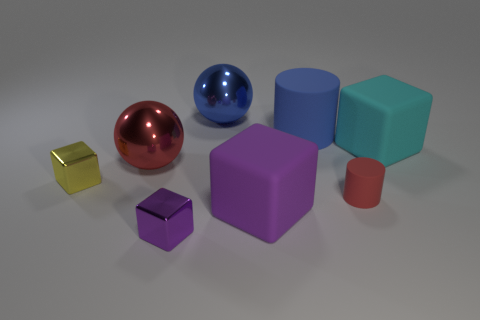Are the cylinder behind the tiny cylinder and the big red thing made of the same material?
Provide a succinct answer. No. Is there a big rubber sphere?
Offer a terse response. No. What size is the red object that is the same material as the blue ball?
Offer a very short reply. Large. Is there a large metal ball that has the same color as the tiny matte thing?
Offer a very short reply. Yes. Does the metallic cube right of the small yellow thing have the same color as the large rubber block that is left of the red cylinder?
Your response must be concise. Yes. The metal sphere that is the same color as the big cylinder is what size?
Give a very brief answer. Large. Is there a big red object that has the same material as the blue ball?
Ensure brevity in your answer.  Yes. What color is the tiny rubber cylinder?
Offer a very short reply. Red. There is a metallic block that is right of the small object that is left of the tiny metallic block in front of the tiny cylinder; what size is it?
Make the answer very short. Small. What number of other objects are there of the same shape as the big blue matte thing?
Keep it short and to the point. 1. 